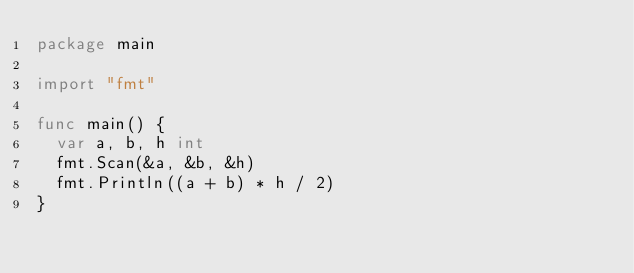<code> <loc_0><loc_0><loc_500><loc_500><_Go_>package main

import "fmt"

func main() {
	var a, b, h int
	fmt.Scan(&a, &b, &h)
	fmt.Println((a + b) * h / 2)
}
</code> 